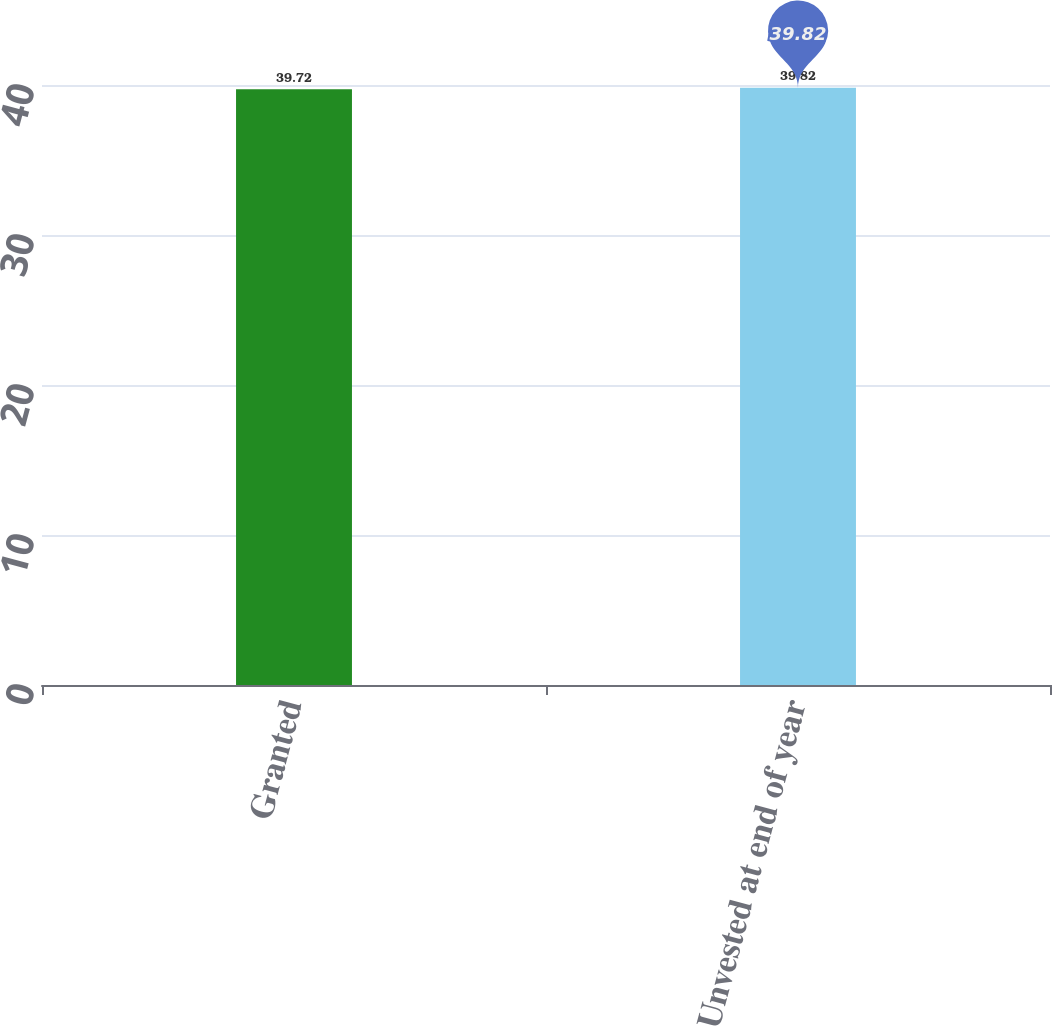Convert chart to OTSL. <chart><loc_0><loc_0><loc_500><loc_500><bar_chart><fcel>Granted<fcel>Unvested at end of year<nl><fcel>39.72<fcel>39.82<nl></chart> 